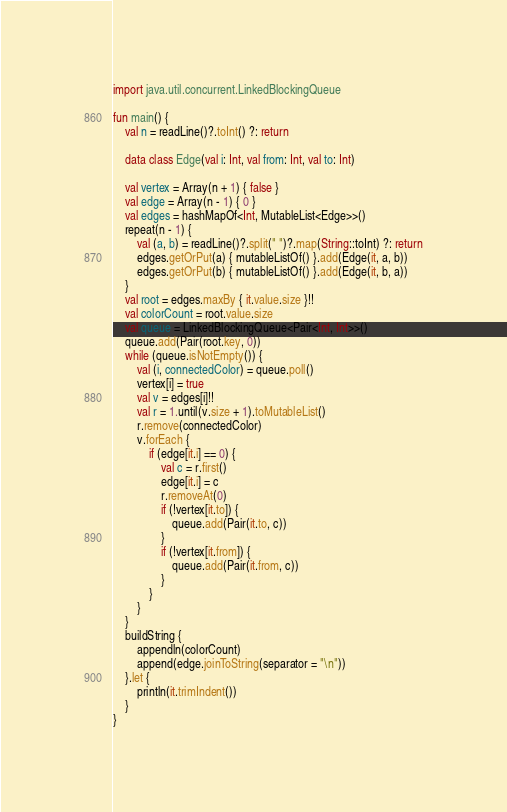Convert code to text. <code><loc_0><loc_0><loc_500><loc_500><_Kotlin_>import java.util.concurrent.LinkedBlockingQueue

fun main() {
    val n = readLine()?.toInt() ?: return

    data class Edge(val i: Int, val from: Int, val to: Int)

    val vertex = Array(n + 1) { false }
    val edge = Array(n - 1) { 0 }
    val edges = hashMapOf<Int, MutableList<Edge>>()
    repeat(n - 1) {
        val (a, b) = readLine()?.split(" ")?.map(String::toInt) ?: return
        edges.getOrPut(a) { mutableListOf() }.add(Edge(it, a, b))
        edges.getOrPut(b) { mutableListOf() }.add(Edge(it, b, a))
    }
    val root = edges.maxBy { it.value.size }!!
    val colorCount = root.value.size
    val queue = LinkedBlockingQueue<Pair<Int, Int>>()
    queue.add(Pair(root.key, 0))
    while (queue.isNotEmpty()) {
        val (i, connectedColor) = queue.poll()
        vertex[i] = true
        val v = edges[i]!!
        val r = 1.until(v.size + 1).toMutableList()
        r.remove(connectedColor)
        v.forEach {
            if (edge[it.i] == 0) {
                val c = r.first()
                edge[it.i] = c
                r.removeAt(0)
                if (!vertex[it.to]) {
                    queue.add(Pair(it.to, c))
                }
                if (!vertex[it.from]) {
                    queue.add(Pair(it.from, c))
                }
            }
        }
    }
    buildString {
        appendln(colorCount)
        append(edge.joinToString(separator = "\n"))
    }.let {
        println(it.trimIndent())
    }
}
</code> 